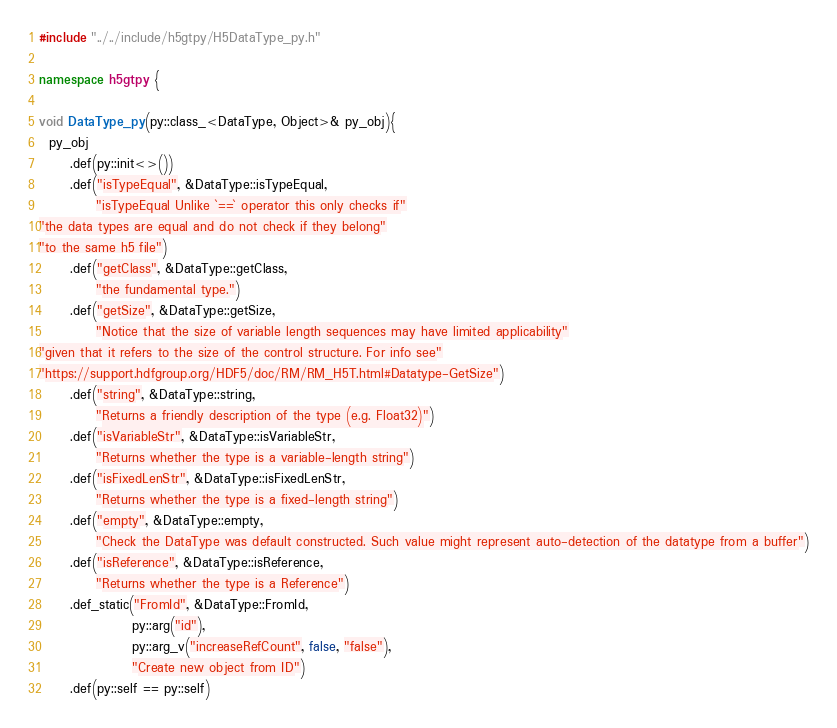<code> <loc_0><loc_0><loc_500><loc_500><_C++_>#include "../../include/h5gtpy/H5DataType_py.h"

namespace h5gtpy {

void DataType_py(py::class_<DataType, Object>& py_obj){
  py_obj
      .def(py::init<>())
      .def("isTypeEqual", &DataType::isTypeEqual,
           "isTypeEqual Unlike `==` operator this only checks if"
"the data types are equal and do not check if they belong"
"to the same h5 file")
      .def("getClass", &DataType::getClass,
           "the fundamental type.")
      .def("getSize", &DataType::getSize,
           "Notice that the size of variable length sequences may have limited applicability"
"given that it refers to the size of the control structure. For info see"
"https://support.hdfgroup.org/HDF5/doc/RM/RM_H5T.html#Datatype-GetSize")
      .def("string", &DataType::string,
           "Returns a friendly description of the type (e.g. Float32)")
      .def("isVariableStr", &DataType::isVariableStr,
           "Returns whether the type is a variable-length string")
      .def("isFixedLenStr", &DataType::isFixedLenStr,
           "Returns whether the type is a fixed-length string")
      .def("empty", &DataType::empty,
           "Check the DataType was default constructed. Such value might represent auto-detection of the datatype from a buffer")
      .def("isReference", &DataType::isReference,
           "Returns whether the type is a Reference")
      .def_static("FromId", &DataType::FromId,
                  py::arg("id"),
                  py::arg_v("increaseRefCount", false, "false"),
                  "Create new object from ID")
      .def(py::self == py::self)</code> 